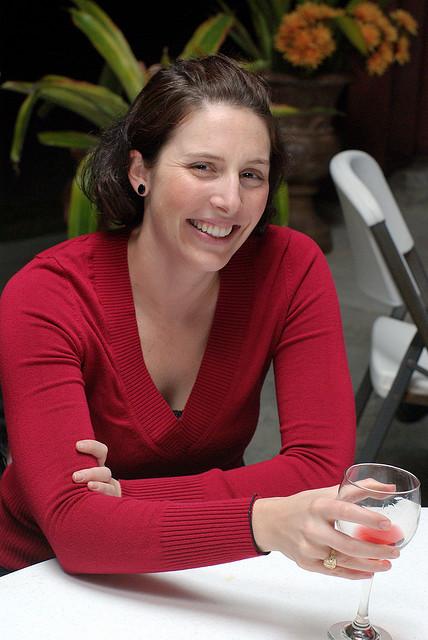Is her shirt striped?
Be succinct. No. What color is her bathing suit?
Answer briefly. Red. Is the wine glass right side up?
Short answer required. Yes. What color is the woman's shirt?
Answer briefly. Red. What color shirt is this person wearing?
Quick response, please. Red. Is it lunch time?
Quick response, please. Yes. What color are the sticks in the vase?
Short answer required. Green. Does she look happy?
Be succinct. Yes. What state is on this woman's shirt?
Keep it brief. None. Is this a birthday party?
Concise answer only. No. What is she using?
Short answer required. Wine glass. What is she holding?
Write a very short answer. Wine glass. Is she smiling?
Be succinct. Yes. Does the woman's dress have sleeves?
Quick response, please. Yes. Is she eating?
Write a very short answer. No. What is the woman doing with her left hand?
Quick response, please. Holding her arm. What are the colors of the women's shirt?
Give a very brief answer. Red. What beverage does the woman have?
Be succinct. Wine. How many people are in this picture?
Keep it brief. 1. How many faces do you see?
Be succinct. 1. What is in the girls hand?
Give a very brief answer. Glass. What race is the woman?
Short answer required. White. Is the woman pouring wine?
Concise answer only. No. What is a more polite synonym for the last word in the thought bubble?
Short answer required. Hello. What is the red object on the woman's waist?
Be succinct. Shirt. What is the table made out of?
Be succinct. Plastic. Is that a boy or girl?
Answer briefly. Girl. What type of gem do the rings around each layer look like?
Be succinct. Diamond. Is there a towel?
Short answer required. No. How many people are in the picture?
Answer briefly. 1. What is she eating?
Answer briefly. Wine. Does the woman have curly or straight hair?
Be succinct. Straight. What type of drink is in the bottle?
Short answer required. Wine. Is she having birthday cake?
Give a very brief answer. No. What is this person holding?
Keep it brief. Wine glass. Which hand is holding the glass?
Concise answer only. Right. What color is the woman's top?
Quick response, please. Red. What is in the glass on the table?
Be succinct. Wine. Is this woman drunk yet?
Give a very brief answer. No. Where is the woman sitting?
Answer briefly. Table. Is this woman young or old?
Give a very brief answer. Young. What is the girl holding?
Answer briefly. Wine glass. 